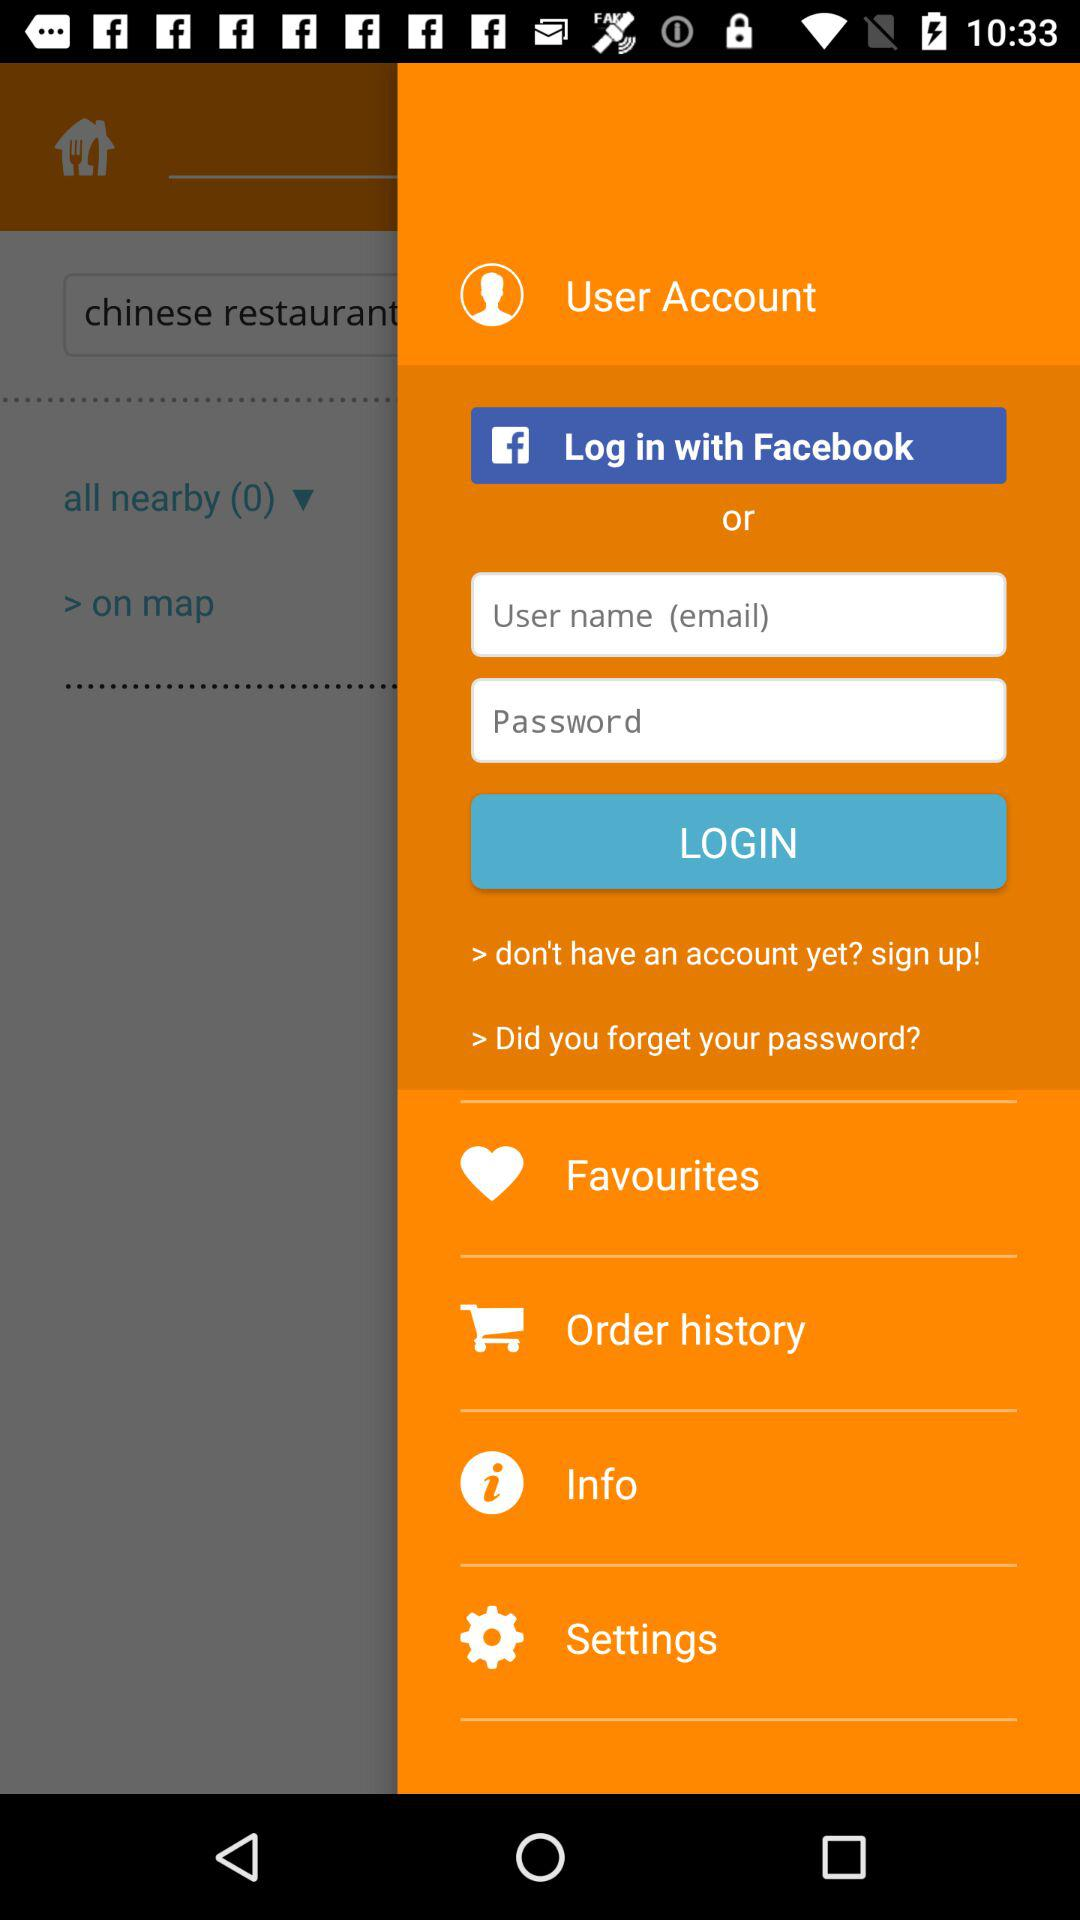What are the login options? The login options are "Facebook" and "User name (email)". 